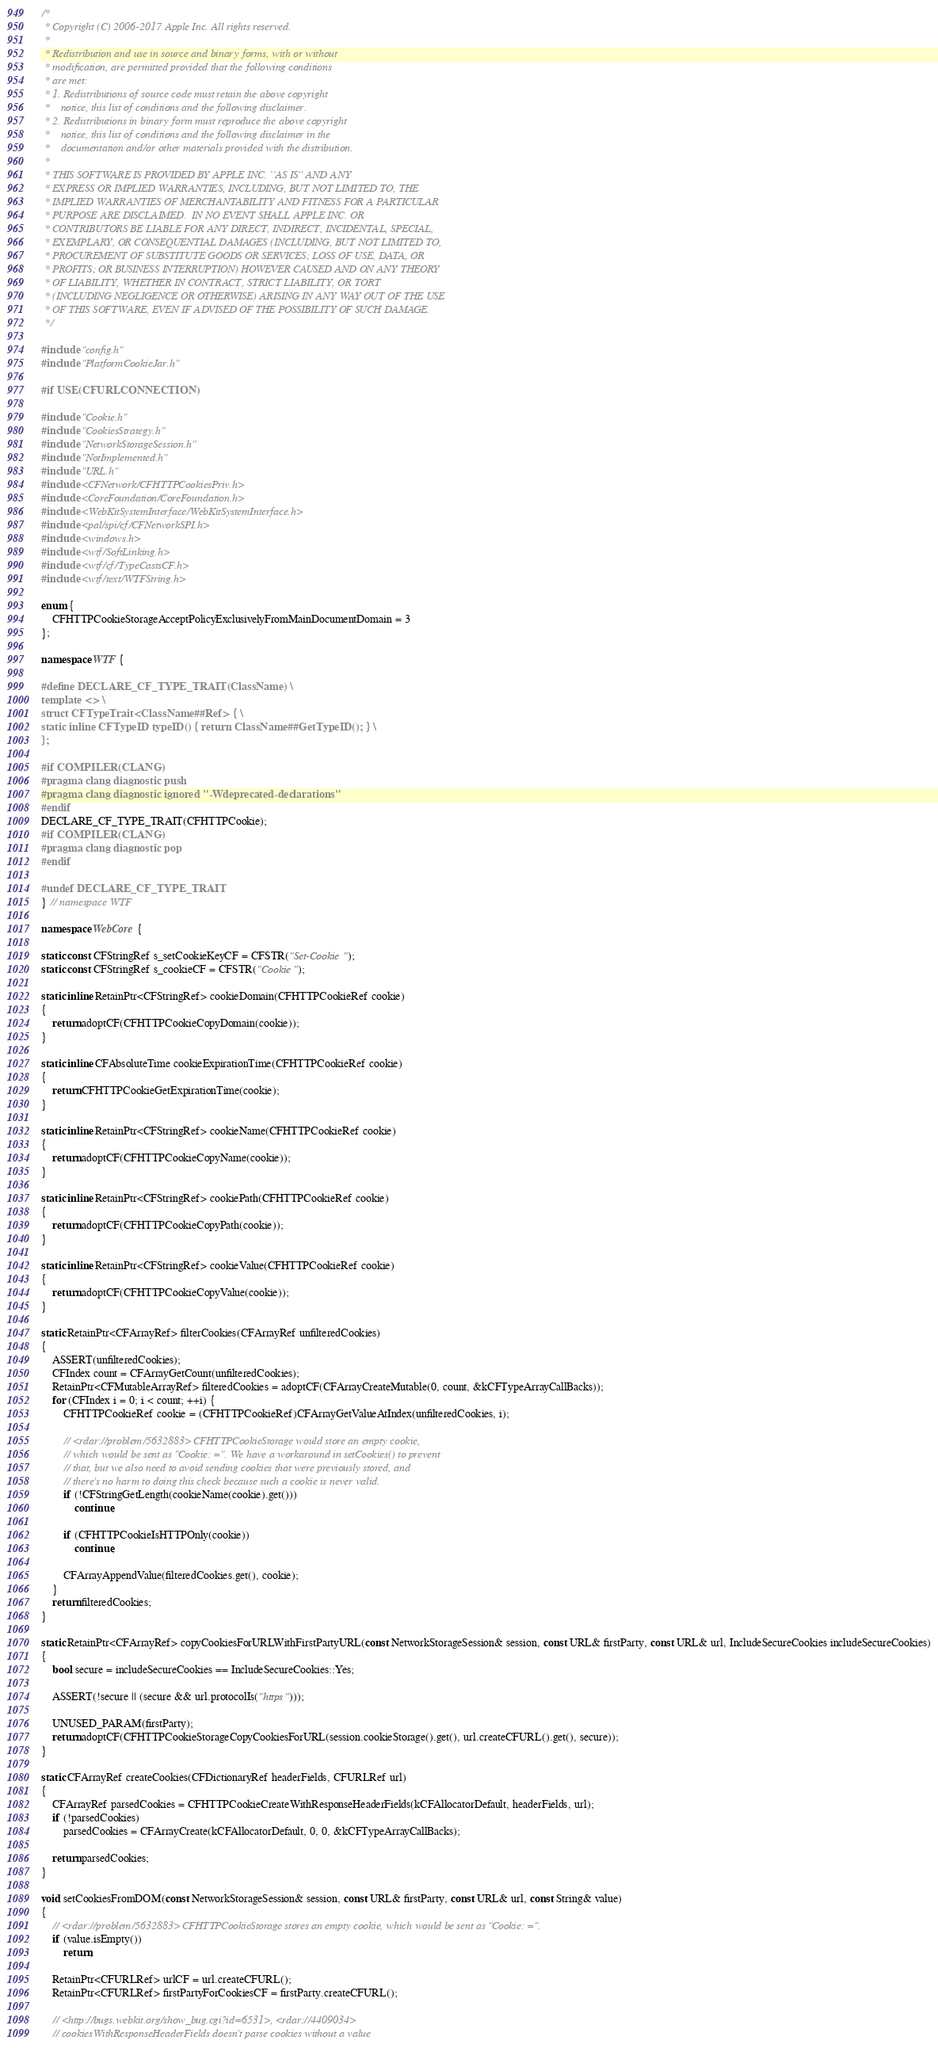<code> <loc_0><loc_0><loc_500><loc_500><_C++_>/*
 * Copyright (C) 2006-2017 Apple Inc. All rights reserved.
 *
 * Redistribution and use in source and binary forms, with or without
 * modification, are permitted provided that the following conditions
 * are met:
 * 1. Redistributions of source code must retain the above copyright
 *    notice, this list of conditions and the following disclaimer.
 * 2. Redistributions in binary form must reproduce the above copyright
 *    notice, this list of conditions and the following disclaimer in the
 *    documentation and/or other materials provided with the distribution.
 *
 * THIS SOFTWARE IS PROVIDED BY APPLE INC. ``AS IS'' AND ANY
 * EXPRESS OR IMPLIED WARRANTIES, INCLUDING, BUT NOT LIMITED TO, THE
 * IMPLIED WARRANTIES OF MERCHANTABILITY AND FITNESS FOR A PARTICULAR
 * PURPOSE ARE DISCLAIMED.  IN NO EVENT SHALL APPLE INC. OR
 * CONTRIBUTORS BE LIABLE FOR ANY DIRECT, INDIRECT, INCIDENTAL, SPECIAL,
 * EXEMPLARY, OR CONSEQUENTIAL DAMAGES (INCLUDING, BUT NOT LIMITED TO,
 * PROCUREMENT OF SUBSTITUTE GOODS OR SERVICES; LOSS OF USE, DATA, OR
 * PROFITS; OR BUSINESS INTERRUPTION) HOWEVER CAUSED AND ON ANY THEORY
 * OF LIABILITY, WHETHER IN CONTRACT, STRICT LIABILITY, OR TORT
 * (INCLUDING NEGLIGENCE OR OTHERWISE) ARISING IN ANY WAY OUT OF THE USE
 * OF THIS SOFTWARE, EVEN IF ADVISED OF THE POSSIBILITY OF SUCH DAMAGE. 
 */

#include "config.h"
#include "PlatformCookieJar.h"

#if USE(CFURLCONNECTION)

#include "Cookie.h"
#include "CookiesStrategy.h"
#include "NetworkStorageSession.h"
#include "NotImplemented.h"
#include "URL.h"
#include <CFNetwork/CFHTTPCookiesPriv.h>
#include <CoreFoundation/CoreFoundation.h>
#include <WebKitSystemInterface/WebKitSystemInterface.h>
#include <pal/spi/cf/CFNetworkSPI.h>
#include <windows.h>
#include <wtf/SoftLinking.h>
#include <wtf/cf/TypeCastsCF.h>
#include <wtf/text/WTFString.h>

enum {
    CFHTTPCookieStorageAcceptPolicyExclusivelyFromMainDocumentDomain = 3
};

namespace WTF {

#define DECLARE_CF_TYPE_TRAIT(ClassName) \
template <> \
struct CFTypeTrait<ClassName##Ref> { \
static inline CFTypeID typeID() { return ClassName##GetTypeID(); } \
};

#if COMPILER(CLANG)
#pragma clang diagnostic push
#pragma clang diagnostic ignored "-Wdeprecated-declarations"
#endif
DECLARE_CF_TYPE_TRAIT(CFHTTPCookie);
#if COMPILER(CLANG)
#pragma clang diagnostic pop
#endif

#undef DECLARE_CF_TYPE_TRAIT
} // namespace WTF

namespace WebCore {

static const CFStringRef s_setCookieKeyCF = CFSTR("Set-Cookie");
static const CFStringRef s_cookieCF = CFSTR("Cookie");

static inline RetainPtr<CFStringRef> cookieDomain(CFHTTPCookieRef cookie)
{
    return adoptCF(CFHTTPCookieCopyDomain(cookie));
}

static inline CFAbsoluteTime cookieExpirationTime(CFHTTPCookieRef cookie)
{
    return CFHTTPCookieGetExpirationTime(cookie);
}

static inline RetainPtr<CFStringRef> cookieName(CFHTTPCookieRef cookie)
{
    return adoptCF(CFHTTPCookieCopyName(cookie));
}

static inline RetainPtr<CFStringRef> cookiePath(CFHTTPCookieRef cookie)
{
    return adoptCF(CFHTTPCookieCopyPath(cookie));
}

static inline RetainPtr<CFStringRef> cookieValue(CFHTTPCookieRef cookie)
{
    return adoptCF(CFHTTPCookieCopyValue(cookie));
}

static RetainPtr<CFArrayRef> filterCookies(CFArrayRef unfilteredCookies)
{
    ASSERT(unfilteredCookies);
    CFIndex count = CFArrayGetCount(unfilteredCookies);
    RetainPtr<CFMutableArrayRef> filteredCookies = adoptCF(CFArrayCreateMutable(0, count, &kCFTypeArrayCallBacks));
    for (CFIndex i = 0; i < count; ++i) {
        CFHTTPCookieRef cookie = (CFHTTPCookieRef)CFArrayGetValueAtIndex(unfilteredCookies, i);

        // <rdar://problem/5632883> CFHTTPCookieStorage would store an empty cookie,
        // which would be sent as "Cookie: =". We have a workaround in setCookies() to prevent
        // that, but we also need to avoid sending cookies that were previously stored, and
        // there's no harm to doing this check because such a cookie is never valid.
        if (!CFStringGetLength(cookieName(cookie).get()))
            continue;

        if (CFHTTPCookieIsHTTPOnly(cookie))
            continue;

        CFArrayAppendValue(filteredCookies.get(), cookie);
    }
    return filteredCookies;
}

static RetainPtr<CFArrayRef> copyCookiesForURLWithFirstPartyURL(const NetworkStorageSession& session, const URL& firstParty, const URL& url, IncludeSecureCookies includeSecureCookies)
{
    bool secure = includeSecureCookies == IncludeSecureCookies::Yes;

    ASSERT(!secure || (secure && url.protocolIs("https")));

    UNUSED_PARAM(firstParty);
    return adoptCF(CFHTTPCookieStorageCopyCookiesForURL(session.cookieStorage().get(), url.createCFURL().get(), secure));
}

static CFArrayRef createCookies(CFDictionaryRef headerFields, CFURLRef url)
{
    CFArrayRef parsedCookies = CFHTTPCookieCreateWithResponseHeaderFields(kCFAllocatorDefault, headerFields, url);
    if (!parsedCookies)
        parsedCookies = CFArrayCreate(kCFAllocatorDefault, 0, 0, &kCFTypeArrayCallBacks);

    return parsedCookies;
}

void setCookiesFromDOM(const NetworkStorageSession& session, const URL& firstParty, const URL& url, const String& value)
{
    // <rdar://problem/5632883> CFHTTPCookieStorage stores an empty cookie, which would be sent as "Cookie: =".
    if (value.isEmpty())
        return;

    RetainPtr<CFURLRef> urlCF = url.createCFURL();
    RetainPtr<CFURLRef> firstPartyForCookiesCF = firstParty.createCFURL();

    // <http://bugs.webkit.org/show_bug.cgi?id=6531>, <rdar://4409034>
    // cookiesWithResponseHeaderFields doesn't parse cookies without a value</code> 